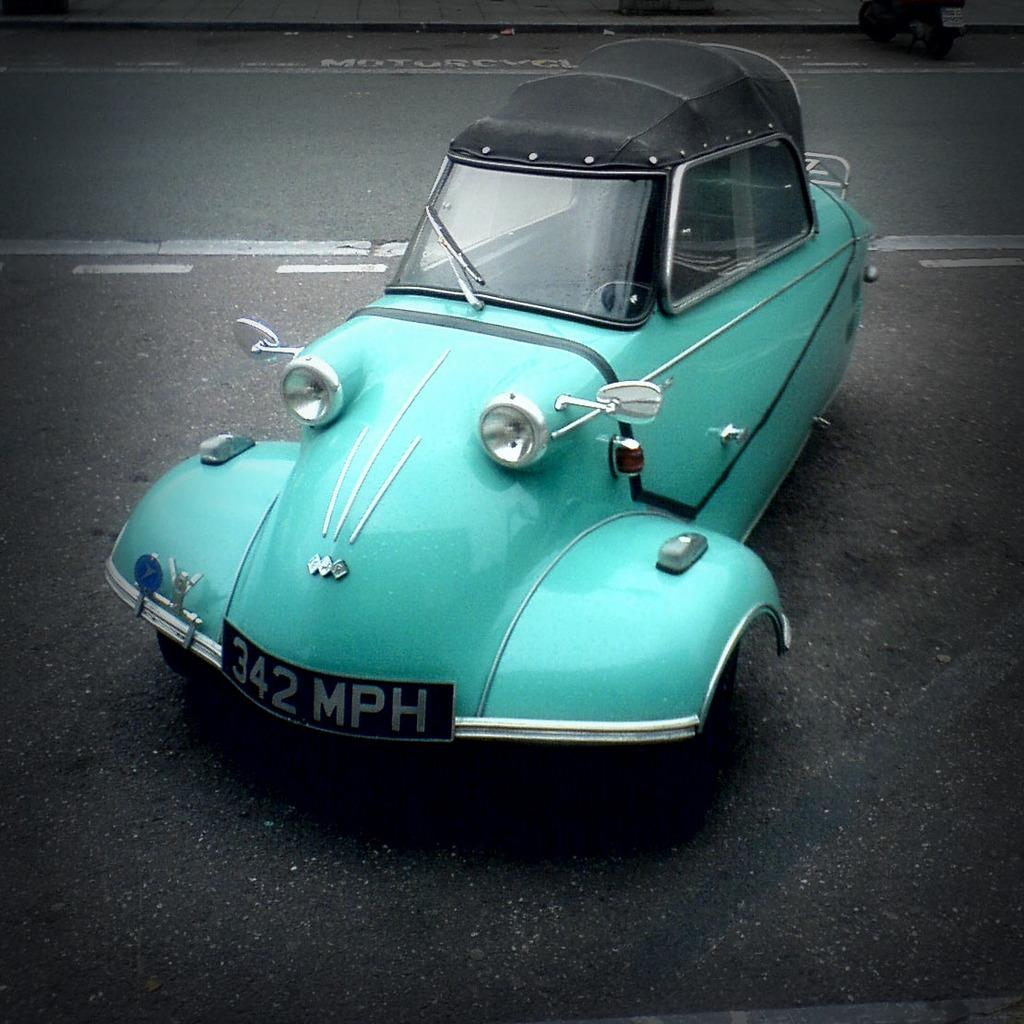What is the main subject of the image? The main subject of the image is a car. Where is the car located in the image? The car is on the road in the image. What color is the car? The car is blue in color. What type of sponge is being used to clean the car in the image? There is no sponge present in the image, and the car is not being cleaned. 